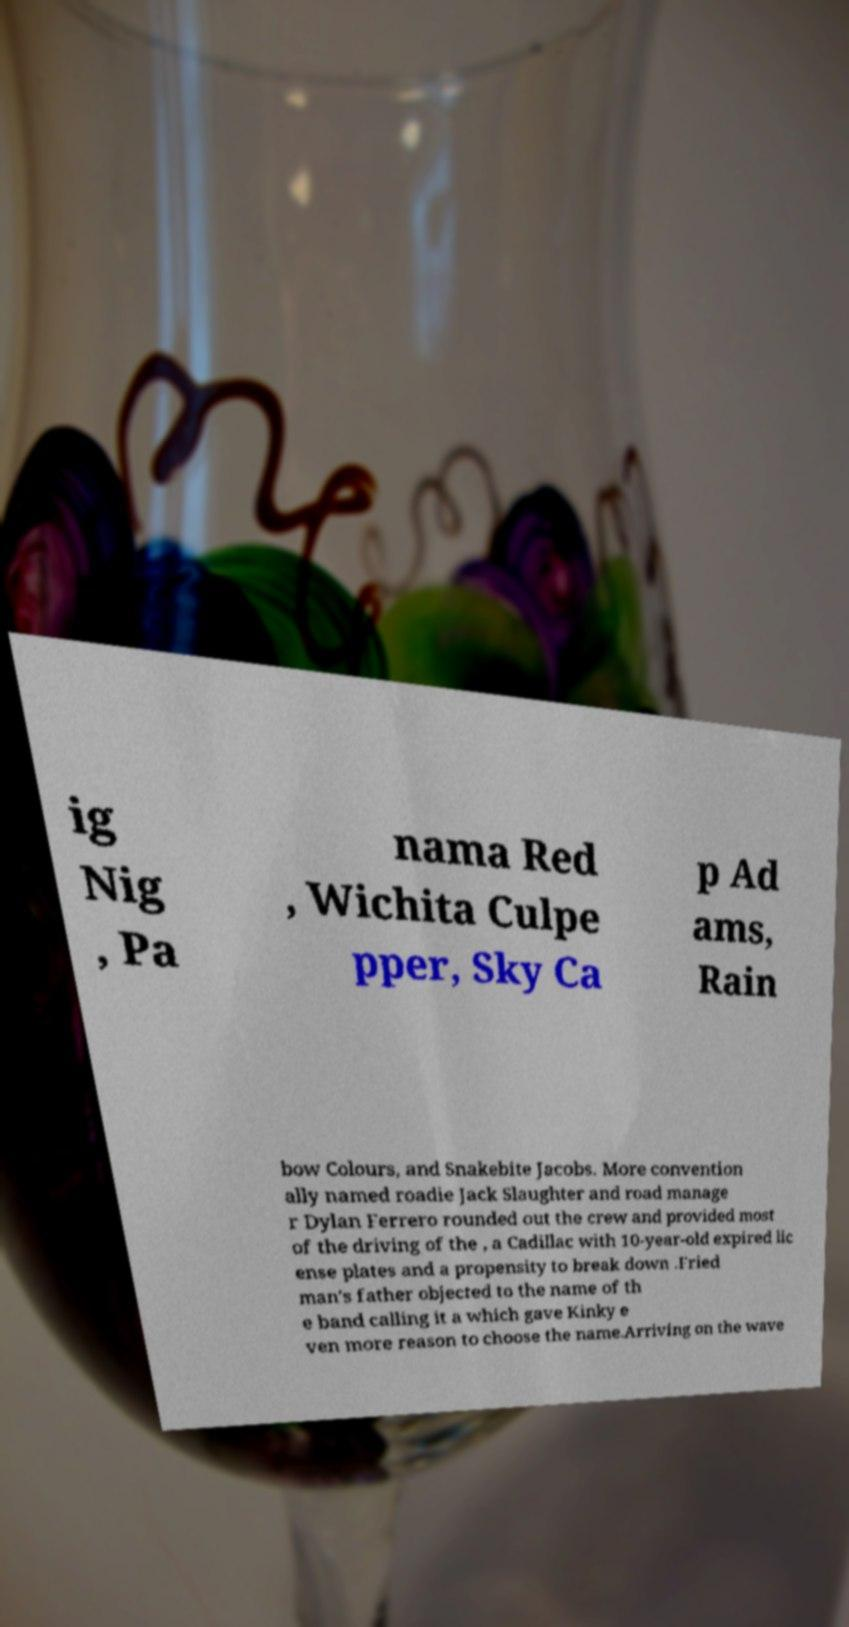Can you accurately transcribe the text from the provided image for me? ig Nig , Pa nama Red , Wichita Culpe pper, Sky Ca p Ad ams, Rain bow Colours, and Snakebite Jacobs. More convention ally named roadie Jack Slaughter and road manage r Dylan Ferrero rounded out the crew and provided most of the driving of the , a Cadillac with 10-year-old expired lic ense plates and a propensity to break down .Fried man's father objected to the name of th e band calling it a which gave Kinky e ven more reason to choose the name.Arriving on the wave 